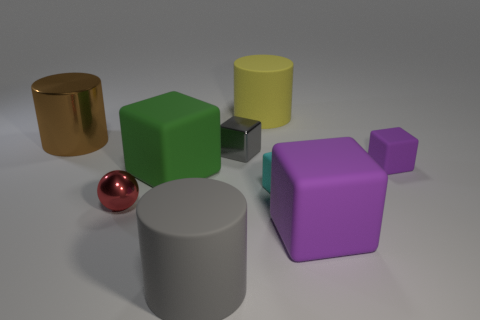What number of objects are either large cubes or matte things on the right side of the yellow rubber cylinder?
Make the answer very short. 4. How many matte cylinders are the same size as the red metallic object?
Offer a terse response. 0. How many yellow things are tiny spheres or large balls?
Make the answer very short. 0. The large rubber thing that is behind the large cylinder that is to the left of the gray cylinder is what shape?
Make the answer very short. Cylinder. The yellow matte thing that is the same size as the green rubber cube is what shape?
Offer a terse response. Cylinder. Are there any objects of the same color as the metal block?
Your answer should be very brief. Yes. Are there the same number of brown objects that are right of the cyan rubber block and rubber blocks that are left of the big gray cylinder?
Provide a short and direct response. No. There is a large purple matte object; is its shape the same as the large rubber object that is behind the gray block?
Keep it short and to the point. No. What number of other things are there of the same material as the small ball
Make the answer very short. 2. Are there any cyan rubber objects behind the big yellow rubber cylinder?
Offer a very short reply. No. 